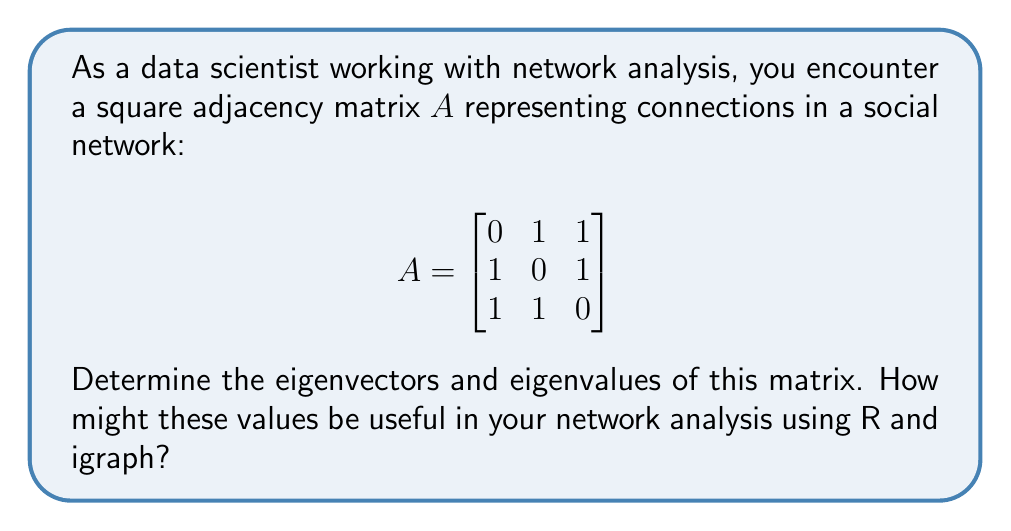Solve this math problem. To find the eigenvectors and eigenvalues of matrix $A$, we follow these steps:

1) First, we need to solve the characteristic equation:
   $\det(A - \lambda I) = 0$

   Where $I$ is the 3x3 identity matrix and $\lambda$ represents the eigenvalues.

2) Expanding the determinant:
   $$\det\begin{bmatrix}
   -\lambda & 1 & 1 \\
   1 & -\lambda & 1 \\
   1 & 1 & -\lambda
   \end{bmatrix} = 0$$

3) Calculating the determinant:
   $-\lambda^3 + 3\lambda + 2 = 0$

4) Solving this equation:
   $(\lambda + 1)^2(\lambda - 2) = 0$

   So, the eigenvalues are: $\lambda_1 = 2$, $\lambda_2 = \lambda_3 = -1$

5) For each eigenvalue, we solve $(A - \lambda I)\vec{v} = \vec{0}$ to find the eigenvectors:

   For $\lambda_1 = 2$:
   $$\begin{bmatrix}
   -2 & 1 & 1 \\
   1 & -2 & 1 \\
   1 & 1 & -2
   \end{bmatrix}\vec{v} = \vec{0}$$

   Solving this gives us: $\vec{v}_1 = [1, 1, 1]^T$

   For $\lambda_2 = \lambda_3 = -1$:
   $$\begin{bmatrix}
   1 & 1 & 1 \\
   1 & 1 & 1 \\
   1 & 1 & 1
   \end{bmatrix}\vec{v} = \vec{0}$$

   Two linearly independent solutions are: $\vec{v}_2 = [1, -1, 0]^T$ and $\vec{v}_3 = [1, 0, -1]^T$

In network analysis using R and igraph:
- The largest eigenvalue (2) and its corresponding eigenvector can indicate the most influential nodes in the network.
- The multiplicity of the smaller eigenvalue (-1) suggests symmetry in the network structure.
- These values can be used for spectral clustering, community detection, and measuring network centrality.
Answer: Eigenvalues: $\lambda_1 = 2$, $\lambda_2 = \lambda_3 = -1$

Eigenvectors: 
$\vec{v}_1 = [1, 1, 1]^T$
$\vec{v}_2 = [1, -1, 0]^T$
$\vec{v}_3 = [1, 0, -1]^T$ 